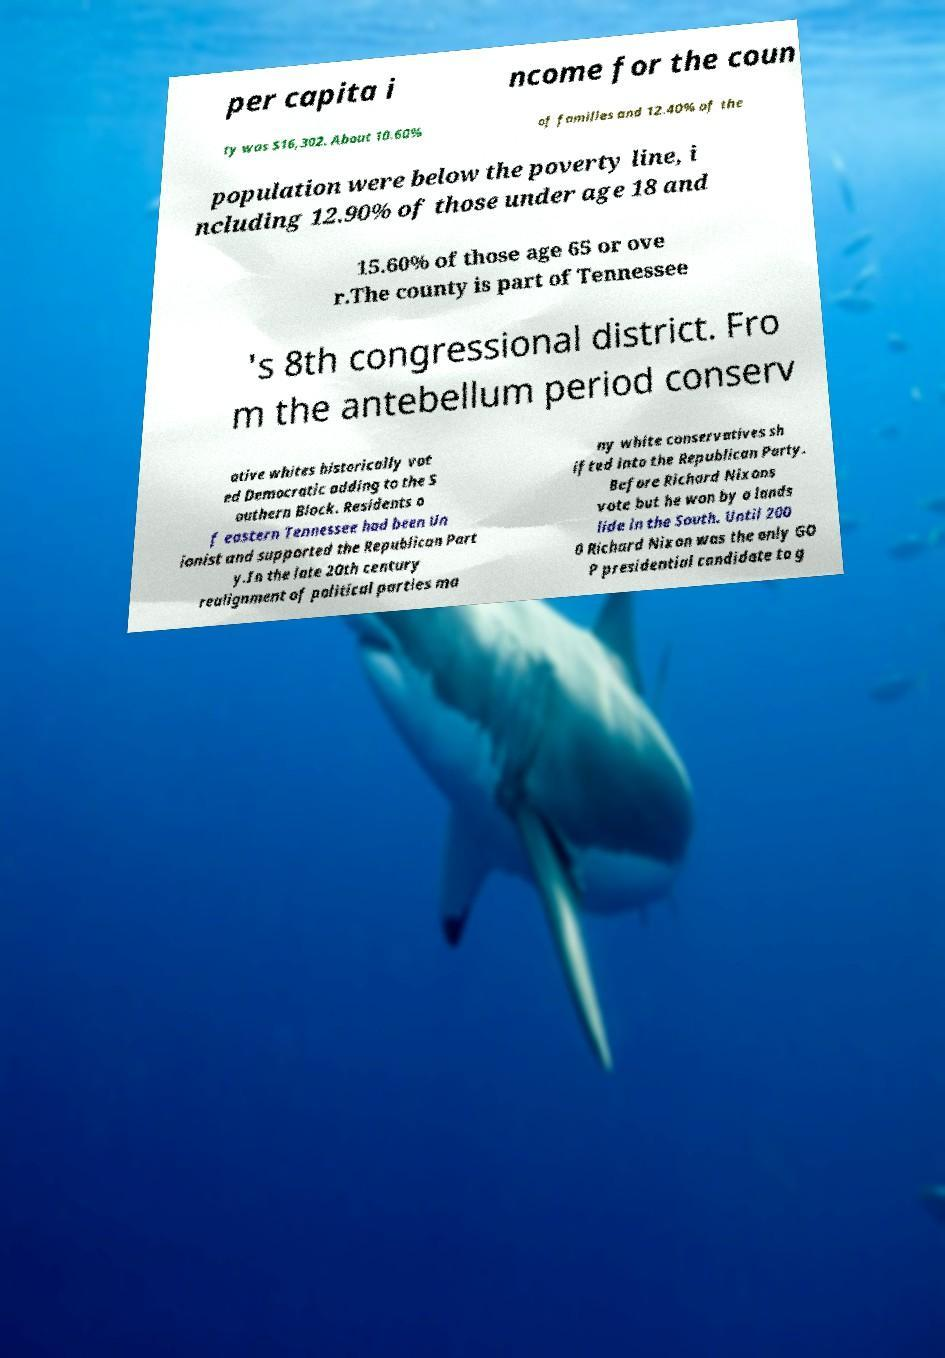For documentation purposes, I need the text within this image transcribed. Could you provide that? per capita i ncome for the coun ty was $16,302. About 10.60% of families and 12.40% of the population were below the poverty line, i ncluding 12.90% of those under age 18 and 15.60% of those age 65 or ove r.The county is part of Tennessee 's 8th congressional district. Fro m the antebellum period conserv ative whites historically vot ed Democratic adding to the S outhern Block. Residents o f eastern Tennessee had been Un ionist and supported the Republican Part y.In the late 20th century realignment of political parties ma ny white conservatives sh ifted into the Republican Party. Before Richard Nixons vote but he won by a lands lide in the South. Until 200 0 Richard Nixon was the only GO P presidential candidate to g 